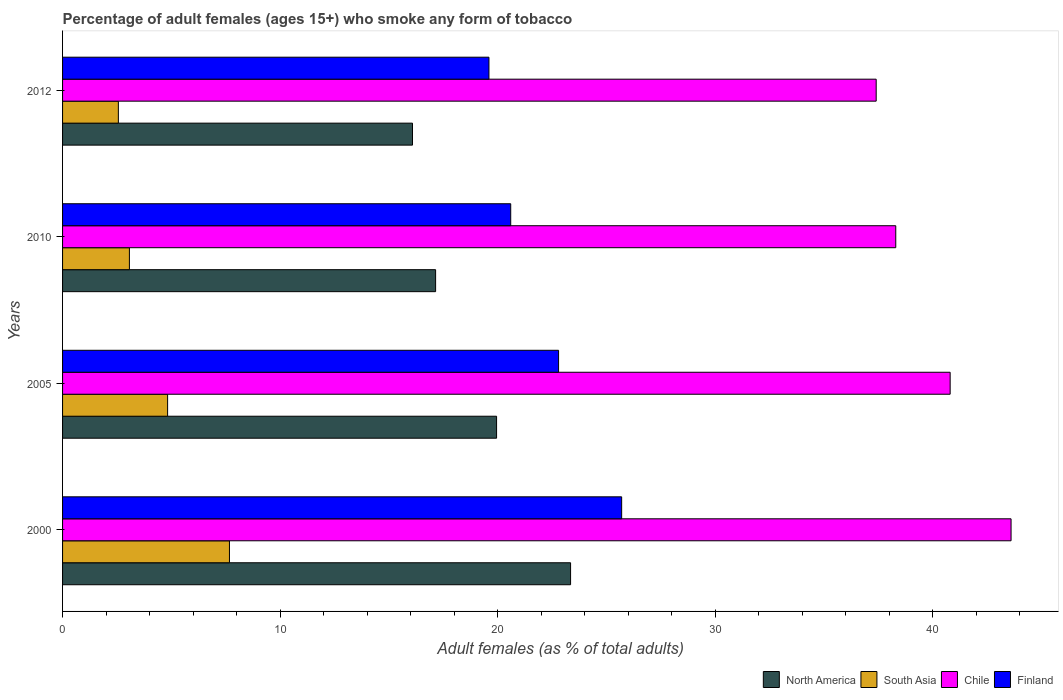How many different coloured bars are there?
Give a very brief answer. 4. How many groups of bars are there?
Your response must be concise. 4. Are the number of bars per tick equal to the number of legend labels?
Keep it short and to the point. Yes. Are the number of bars on each tick of the Y-axis equal?
Offer a terse response. Yes. How many bars are there on the 2nd tick from the bottom?
Provide a short and direct response. 4. In how many cases, is the number of bars for a given year not equal to the number of legend labels?
Offer a very short reply. 0. What is the percentage of adult females who smoke in North America in 2012?
Offer a very short reply. 16.09. Across all years, what is the maximum percentage of adult females who smoke in Chile?
Make the answer very short. 43.6. Across all years, what is the minimum percentage of adult females who smoke in North America?
Offer a terse response. 16.09. What is the total percentage of adult females who smoke in South Asia in the graph?
Provide a short and direct response. 18.14. What is the difference between the percentage of adult females who smoke in North America in 2000 and that in 2010?
Offer a terse response. 6.2. What is the difference between the percentage of adult females who smoke in Finland in 2005 and the percentage of adult females who smoke in South Asia in 2012?
Make the answer very short. 20.24. What is the average percentage of adult females who smoke in Finland per year?
Give a very brief answer. 22.17. In the year 2005, what is the difference between the percentage of adult females who smoke in South Asia and percentage of adult females who smoke in Chile?
Offer a terse response. -35.97. What is the ratio of the percentage of adult females who smoke in Finland in 2010 to that in 2012?
Give a very brief answer. 1.05. Is the difference between the percentage of adult females who smoke in South Asia in 2005 and 2010 greater than the difference between the percentage of adult females who smoke in Chile in 2005 and 2010?
Give a very brief answer. No. What is the difference between the highest and the second highest percentage of adult females who smoke in North America?
Your response must be concise. 3.4. What is the difference between the highest and the lowest percentage of adult females who smoke in South Asia?
Provide a succinct answer. 5.11. In how many years, is the percentage of adult females who smoke in South Asia greater than the average percentage of adult females who smoke in South Asia taken over all years?
Provide a succinct answer. 2. Is the sum of the percentage of adult females who smoke in North America in 2000 and 2010 greater than the maximum percentage of adult females who smoke in South Asia across all years?
Your response must be concise. Yes. What does the 2nd bar from the bottom in 2005 represents?
Your answer should be compact. South Asia. Are all the bars in the graph horizontal?
Provide a succinct answer. Yes. How many years are there in the graph?
Provide a short and direct response. 4. What is the difference between two consecutive major ticks on the X-axis?
Your response must be concise. 10. Are the values on the major ticks of X-axis written in scientific E-notation?
Keep it short and to the point. No. Does the graph contain any zero values?
Ensure brevity in your answer.  No. Does the graph contain grids?
Offer a very short reply. No. How are the legend labels stacked?
Offer a very short reply. Horizontal. What is the title of the graph?
Make the answer very short. Percentage of adult females (ages 15+) who smoke any form of tobacco. What is the label or title of the X-axis?
Your response must be concise. Adult females (as % of total adults). What is the label or title of the Y-axis?
Give a very brief answer. Years. What is the Adult females (as % of total adults) in North America in 2000?
Provide a short and direct response. 23.35. What is the Adult females (as % of total adults) of South Asia in 2000?
Your response must be concise. 7.67. What is the Adult females (as % of total adults) of Chile in 2000?
Provide a succinct answer. 43.6. What is the Adult females (as % of total adults) in Finland in 2000?
Your response must be concise. 25.7. What is the Adult females (as % of total adults) of North America in 2005?
Provide a succinct answer. 19.95. What is the Adult females (as % of total adults) of South Asia in 2005?
Your answer should be very brief. 4.83. What is the Adult females (as % of total adults) in Chile in 2005?
Give a very brief answer. 40.8. What is the Adult females (as % of total adults) of Finland in 2005?
Offer a terse response. 22.8. What is the Adult females (as % of total adults) of North America in 2010?
Give a very brief answer. 17.15. What is the Adult females (as % of total adults) in South Asia in 2010?
Your answer should be compact. 3.07. What is the Adult females (as % of total adults) of Chile in 2010?
Offer a terse response. 38.3. What is the Adult females (as % of total adults) in Finland in 2010?
Make the answer very short. 20.6. What is the Adult females (as % of total adults) of North America in 2012?
Offer a terse response. 16.09. What is the Adult females (as % of total adults) in South Asia in 2012?
Keep it short and to the point. 2.56. What is the Adult females (as % of total adults) of Chile in 2012?
Your response must be concise. 37.4. What is the Adult females (as % of total adults) in Finland in 2012?
Your answer should be very brief. 19.6. Across all years, what is the maximum Adult females (as % of total adults) in North America?
Give a very brief answer. 23.35. Across all years, what is the maximum Adult females (as % of total adults) of South Asia?
Your response must be concise. 7.67. Across all years, what is the maximum Adult females (as % of total adults) in Chile?
Offer a very short reply. 43.6. Across all years, what is the maximum Adult females (as % of total adults) of Finland?
Ensure brevity in your answer.  25.7. Across all years, what is the minimum Adult females (as % of total adults) in North America?
Give a very brief answer. 16.09. Across all years, what is the minimum Adult females (as % of total adults) of South Asia?
Your response must be concise. 2.56. Across all years, what is the minimum Adult females (as % of total adults) in Chile?
Your response must be concise. 37.4. Across all years, what is the minimum Adult females (as % of total adults) of Finland?
Your answer should be compact. 19.6. What is the total Adult females (as % of total adults) in North America in the graph?
Make the answer very short. 76.54. What is the total Adult females (as % of total adults) of South Asia in the graph?
Provide a short and direct response. 18.14. What is the total Adult females (as % of total adults) in Chile in the graph?
Your answer should be compact. 160.1. What is the total Adult females (as % of total adults) of Finland in the graph?
Ensure brevity in your answer.  88.7. What is the difference between the Adult females (as % of total adults) in North America in 2000 and that in 2005?
Keep it short and to the point. 3.4. What is the difference between the Adult females (as % of total adults) in South Asia in 2000 and that in 2005?
Ensure brevity in your answer.  2.84. What is the difference between the Adult females (as % of total adults) in Finland in 2000 and that in 2005?
Make the answer very short. 2.9. What is the difference between the Adult females (as % of total adults) in North America in 2000 and that in 2010?
Provide a succinct answer. 6.2. What is the difference between the Adult females (as % of total adults) in South Asia in 2000 and that in 2010?
Your response must be concise. 4.6. What is the difference between the Adult females (as % of total adults) of Finland in 2000 and that in 2010?
Your response must be concise. 5.1. What is the difference between the Adult females (as % of total adults) in North America in 2000 and that in 2012?
Your answer should be compact. 7.27. What is the difference between the Adult females (as % of total adults) in South Asia in 2000 and that in 2012?
Your response must be concise. 5.11. What is the difference between the Adult females (as % of total adults) in North America in 2005 and that in 2010?
Your answer should be very brief. 2.8. What is the difference between the Adult females (as % of total adults) of South Asia in 2005 and that in 2010?
Ensure brevity in your answer.  1.76. What is the difference between the Adult females (as % of total adults) of Chile in 2005 and that in 2010?
Your response must be concise. 2.5. What is the difference between the Adult females (as % of total adults) of Finland in 2005 and that in 2010?
Keep it short and to the point. 2.2. What is the difference between the Adult females (as % of total adults) of North America in 2005 and that in 2012?
Ensure brevity in your answer.  3.86. What is the difference between the Adult females (as % of total adults) of South Asia in 2005 and that in 2012?
Provide a short and direct response. 2.26. What is the difference between the Adult females (as % of total adults) of Chile in 2005 and that in 2012?
Offer a terse response. 3.4. What is the difference between the Adult females (as % of total adults) of North America in 2010 and that in 2012?
Provide a succinct answer. 1.06. What is the difference between the Adult females (as % of total adults) in South Asia in 2010 and that in 2012?
Offer a terse response. 0.51. What is the difference between the Adult females (as % of total adults) in North America in 2000 and the Adult females (as % of total adults) in South Asia in 2005?
Give a very brief answer. 18.52. What is the difference between the Adult females (as % of total adults) in North America in 2000 and the Adult females (as % of total adults) in Chile in 2005?
Offer a terse response. -17.45. What is the difference between the Adult females (as % of total adults) in North America in 2000 and the Adult females (as % of total adults) in Finland in 2005?
Make the answer very short. 0.55. What is the difference between the Adult females (as % of total adults) in South Asia in 2000 and the Adult females (as % of total adults) in Chile in 2005?
Offer a terse response. -33.13. What is the difference between the Adult females (as % of total adults) of South Asia in 2000 and the Adult females (as % of total adults) of Finland in 2005?
Give a very brief answer. -15.13. What is the difference between the Adult females (as % of total adults) of Chile in 2000 and the Adult females (as % of total adults) of Finland in 2005?
Your answer should be very brief. 20.8. What is the difference between the Adult females (as % of total adults) in North America in 2000 and the Adult females (as % of total adults) in South Asia in 2010?
Your answer should be compact. 20.28. What is the difference between the Adult females (as % of total adults) of North America in 2000 and the Adult females (as % of total adults) of Chile in 2010?
Keep it short and to the point. -14.95. What is the difference between the Adult females (as % of total adults) of North America in 2000 and the Adult females (as % of total adults) of Finland in 2010?
Ensure brevity in your answer.  2.75. What is the difference between the Adult females (as % of total adults) in South Asia in 2000 and the Adult females (as % of total adults) in Chile in 2010?
Offer a very short reply. -30.63. What is the difference between the Adult females (as % of total adults) of South Asia in 2000 and the Adult females (as % of total adults) of Finland in 2010?
Provide a short and direct response. -12.93. What is the difference between the Adult females (as % of total adults) in North America in 2000 and the Adult females (as % of total adults) in South Asia in 2012?
Provide a short and direct response. 20.79. What is the difference between the Adult females (as % of total adults) of North America in 2000 and the Adult females (as % of total adults) of Chile in 2012?
Your response must be concise. -14.05. What is the difference between the Adult females (as % of total adults) in North America in 2000 and the Adult females (as % of total adults) in Finland in 2012?
Keep it short and to the point. 3.75. What is the difference between the Adult females (as % of total adults) in South Asia in 2000 and the Adult females (as % of total adults) in Chile in 2012?
Make the answer very short. -29.73. What is the difference between the Adult females (as % of total adults) in South Asia in 2000 and the Adult females (as % of total adults) in Finland in 2012?
Provide a succinct answer. -11.93. What is the difference between the Adult females (as % of total adults) in Chile in 2000 and the Adult females (as % of total adults) in Finland in 2012?
Offer a terse response. 24. What is the difference between the Adult females (as % of total adults) of North America in 2005 and the Adult females (as % of total adults) of South Asia in 2010?
Your answer should be compact. 16.88. What is the difference between the Adult females (as % of total adults) of North America in 2005 and the Adult females (as % of total adults) of Chile in 2010?
Your response must be concise. -18.35. What is the difference between the Adult females (as % of total adults) in North America in 2005 and the Adult females (as % of total adults) in Finland in 2010?
Ensure brevity in your answer.  -0.65. What is the difference between the Adult females (as % of total adults) of South Asia in 2005 and the Adult females (as % of total adults) of Chile in 2010?
Your answer should be compact. -33.47. What is the difference between the Adult females (as % of total adults) in South Asia in 2005 and the Adult females (as % of total adults) in Finland in 2010?
Keep it short and to the point. -15.77. What is the difference between the Adult females (as % of total adults) in Chile in 2005 and the Adult females (as % of total adults) in Finland in 2010?
Provide a succinct answer. 20.2. What is the difference between the Adult females (as % of total adults) in North America in 2005 and the Adult females (as % of total adults) in South Asia in 2012?
Your response must be concise. 17.39. What is the difference between the Adult females (as % of total adults) of North America in 2005 and the Adult females (as % of total adults) of Chile in 2012?
Offer a terse response. -17.45. What is the difference between the Adult females (as % of total adults) of North America in 2005 and the Adult females (as % of total adults) of Finland in 2012?
Provide a succinct answer. 0.35. What is the difference between the Adult females (as % of total adults) of South Asia in 2005 and the Adult females (as % of total adults) of Chile in 2012?
Ensure brevity in your answer.  -32.57. What is the difference between the Adult females (as % of total adults) in South Asia in 2005 and the Adult females (as % of total adults) in Finland in 2012?
Provide a short and direct response. -14.77. What is the difference between the Adult females (as % of total adults) in Chile in 2005 and the Adult females (as % of total adults) in Finland in 2012?
Ensure brevity in your answer.  21.2. What is the difference between the Adult females (as % of total adults) of North America in 2010 and the Adult females (as % of total adults) of South Asia in 2012?
Your answer should be very brief. 14.58. What is the difference between the Adult females (as % of total adults) of North America in 2010 and the Adult females (as % of total adults) of Chile in 2012?
Your answer should be very brief. -20.25. What is the difference between the Adult females (as % of total adults) of North America in 2010 and the Adult females (as % of total adults) of Finland in 2012?
Offer a terse response. -2.45. What is the difference between the Adult females (as % of total adults) in South Asia in 2010 and the Adult females (as % of total adults) in Chile in 2012?
Offer a terse response. -34.33. What is the difference between the Adult females (as % of total adults) in South Asia in 2010 and the Adult females (as % of total adults) in Finland in 2012?
Your response must be concise. -16.53. What is the difference between the Adult females (as % of total adults) of Chile in 2010 and the Adult females (as % of total adults) of Finland in 2012?
Provide a succinct answer. 18.7. What is the average Adult females (as % of total adults) of North America per year?
Give a very brief answer. 19.13. What is the average Adult females (as % of total adults) of South Asia per year?
Provide a succinct answer. 4.53. What is the average Adult females (as % of total adults) in Chile per year?
Keep it short and to the point. 40.02. What is the average Adult females (as % of total adults) of Finland per year?
Offer a very short reply. 22.18. In the year 2000, what is the difference between the Adult females (as % of total adults) of North America and Adult females (as % of total adults) of South Asia?
Provide a succinct answer. 15.68. In the year 2000, what is the difference between the Adult females (as % of total adults) of North America and Adult females (as % of total adults) of Chile?
Ensure brevity in your answer.  -20.25. In the year 2000, what is the difference between the Adult females (as % of total adults) in North America and Adult females (as % of total adults) in Finland?
Offer a terse response. -2.35. In the year 2000, what is the difference between the Adult females (as % of total adults) of South Asia and Adult females (as % of total adults) of Chile?
Your answer should be very brief. -35.93. In the year 2000, what is the difference between the Adult females (as % of total adults) of South Asia and Adult females (as % of total adults) of Finland?
Ensure brevity in your answer.  -18.03. In the year 2000, what is the difference between the Adult females (as % of total adults) of Chile and Adult females (as % of total adults) of Finland?
Keep it short and to the point. 17.9. In the year 2005, what is the difference between the Adult females (as % of total adults) of North America and Adult females (as % of total adults) of South Asia?
Provide a succinct answer. 15.12. In the year 2005, what is the difference between the Adult females (as % of total adults) in North America and Adult females (as % of total adults) in Chile?
Keep it short and to the point. -20.85. In the year 2005, what is the difference between the Adult females (as % of total adults) of North America and Adult females (as % of total adults) of Finland?
Keep it short and to the point. -2.85. In the year 2005, what is the difference between the Adult females (as % of total adults) in South Asia and Adult females (as % of total adults) in Chile?
Ensure brevity in your answer.  -35.97. In the year 2005, what is the difference between the Adult females (as % of total adults) in South Asia and Adult females (as % of total adults) in Finland?
Keep it short and to the point. -17.97. In the year 2005, what is the difference between the Adult females (as % of total adults) in Chile and Adult females (as % of total adults) in Finland?
Give a very brief answer. 18. In the year 2010, what is the difference between the Adult females (as % of total adults) in North America and Adult females (as % of total adults) in South Asia?
Keep it short and to the point. 14.08. In the year 2010, what is the difference between the Adult females (as % of total adults) in North America and Adult females (as % of total adults) in Chile?
Ensure brevity in your answer.  -21.15. In the year 2010, what is the difference between the Adult females (as % of total adults) of North America and Adult females (as % of total adults) of Finland?
Keep it short and to the point. -3.45. In the year 2010, what is the difference between the Adult females (as % of total adults) of South Asia and Adult females (as % of total adults) of Chile?
Keep it short and to the point. -35.23. In the year 2010, what is the difference between the Adult females (as % of total adults) of South Asia and Adult females (as % of total adults) of Finland?
Give a very brief answer. -17.53. In the year 2010, what is the difference between the Adult females (as % of total adults) of Chile and Adult females (as % of total adults) of Finland?
Offer a terse response. 17.7. In the year 2012, what is the difference between the Adult females (as % of total adults) in North America and Adult females (as % of total adults) in South Asia?
Your answer should be compact. 13.52. In the year 2012, what is the difference between the Adult females (as % of total adults) of North America and Adult females (as % of total adults) of Chile?
Offer a terse response. -21.31. In the year 2012, what is the difference between the Adult females (as % of total adults) of North America and Adult females (as % of total adults) of Finland?
Your answer should be compact. -3.51. In the year 2012, what is the difference between the Adult females (as % of total adults) of South Asia and Adult females (as % of total adults) of Chile?
Your answer should be compact. -34.84. In the year 2012, what is the difference between the Adult females (as % of total adults) of South Asia and Adult females (as % of total adults) of Finland?
Offer a terse response. -17.04. In the year 2012, what is the difference between the Adult females (as % of total adults) in Chile and Adult females (as % of total adults) in Finland?
Keep it short and to the point. 17.8. What is the ratio of the Adult females (as % of total adults) in North America in 2000 to that in 2005?
Provide a succinct answer. 1.17. What is the ratio of the Adult females (as % of total adults) in South Asia in 2000 to that in 2005?
Provide a succinct answer. 1.59. What is the ratio of the Adult females (as % of total adults) of Chile in 2000 to that in 2005?
Provide a short and direct response. 1.07. What is the ratio of the Adult females (as % of total adults) of Finland in 2000 to that in 2005?
Your answer should be compact. 1.13. What is the ratio of the Adult females (as % of total adults) of North America in 2000 to that in 2010?
Ensure brevity in your answer.  1.36. What is the ratio of the Adult females (as % of total adults) in South Asia in 2000 to that in 2010?
Offer a terse response. 2.5. What is the ratio of the Adult females (as % of total adults) of Chile in 2000 to that in 2010?
Provide a short and direct response. 1.14. What is the ratio of the Adult females (as % of total adults) in Finland in 2000 to that in 2010?
Your response must be concise. 1.25. What is the ratio of the Adult females (as % of total adults) in North America in 2000 to that in 2012?
Your response must be concise. 1.45. What is the ratio of the Adult females (as % of total adults) of South Asia in 2000 to that in 2012?
Your response must be concise. 2.99. What is the ratio of the Adult females (as % of total adults) in Chile in 2000 to that in 2012?
Provide a short and direct response. 1.17. What is the ratio of the Adult females (as % of total adults) of Finland in 2000 to that in 2012?
Provide a short and direct response. 1.31. What is the ratio of the Adult females (as % of total adults) in North America in 2005 to that in 2010?
Your answer should be very brief. 1.16. What is the ratio of the Adult females (as % of total adults) in South Asia in 2005 to that in 2010?
Give a very brief answer. 1.57. What is the ratio of the Adult females (as % of total adults) of Chile in 2005 to that in 2010?
Provide a succinct answer. 1.07. What is the ratio of the Adult females (as % of total adults) of Finland in 2005 to that in 2010?
Make the answer very short. 1.11. What is the ratio of the Adult females (as % of total adults) in North America in 2005 to that in 2012?
Provide a succinct answer. 1.24. What is the ratio of the Adult females (as % of total adults) of South Asia in 2005 to that in 2012?
Offer a terse response. 1.88. What is the ratio of the Adult females (as % of total adults) in Finland in 2005 to that in 2012?
Keep it short and to the point. 1.16. What is the ratio of the Adult females (as % of total adults) in North America in 2010 to that in 2012?
Ensure brevity in your answer.  1.07. What is the ratio of the Adult females (as % of total adults) in South Asia in 2010 to that in 2012?
Your answer should be compact. 1.2. What is the ratio of the Adult females (as % of total adults) in Chile in 2010 to that in 2012?
Your response must be concise. 1.02. What is the ratio of the Adult females (as % of total adults) of Finland in 2010 to that in 2012?
Provide a short and direct response. 1.05. What is the difference between the highest and the second highest Adult females (as % of total adults) of North America?
Give a very brief answer. 3.4. What is the difference between the highest and the second highest Adult females (as % of total adults) in South Asia?
Provide a succinct answer. 2.84. What is the difference between the highest and the lowest Adult females (as % of total adults) in North America?
Offer a terse response. 7.27. What is the difference between the highest and the lowest Adult females (as % of total adults) in South Asia?
Give a very brief answer. 5.11. What is the difference between the highest and the lowest Adult females (as % of total adults) of Chile?
Your response must be concise. 6.2. 